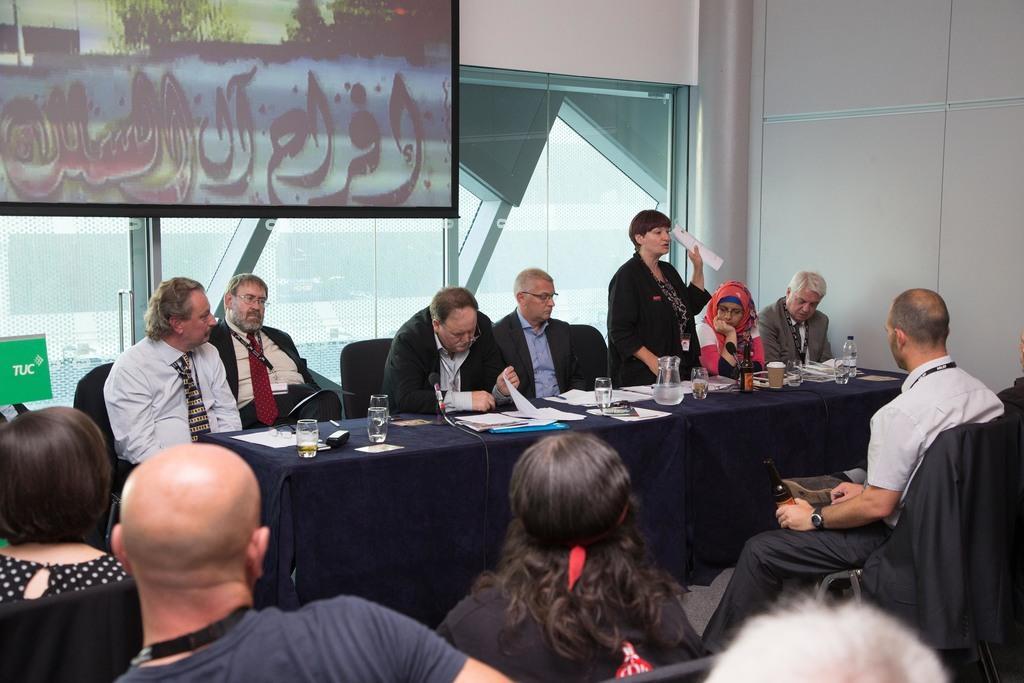In one or two sentences, can you explain what this image depicts? Here in this picture , in the middle we can see a group of people sitting on chairs with table in front of them and we can see a woman standing and speaking something to the people present in front of her, who are sitting in chairs over there and on the table we can see glasses, jars and papers present all over there and behind them on the top we can see a projector screen present and we can also see a window present over there. 